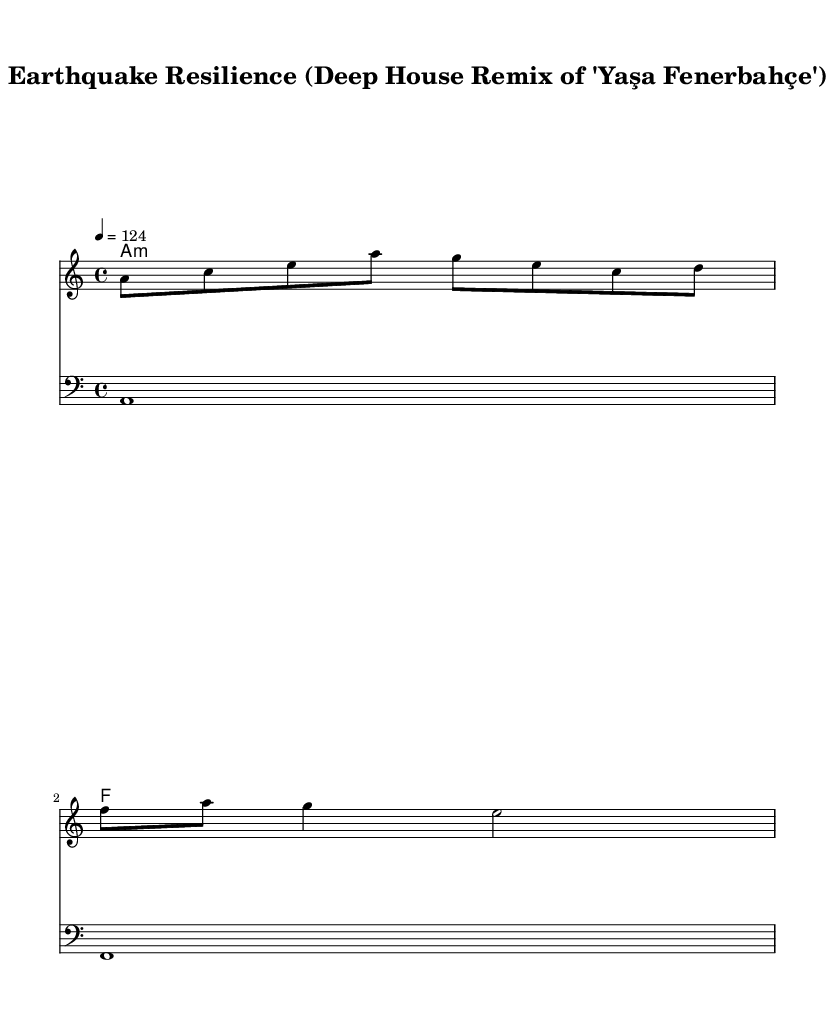What is the key signature of this music? The key signature is indicated at the beginning of the sheet music, showing one flat, which corresponds to A minor.
Answer: A minor What is the time signature of this music? The time signature is found at the beginning of the staff, and it shows that there are four beats in each measure, making it a 4/4 time signature.
Answer: 4/4 What is the tempo of this music? The tempo is provided above the staff, which indicates the speed at which the music should be played; it is marked as 124 beats per minute.
Answer: 124 How many measures are in the melody? By counting the bars in the melody line, we can see there are three measures, as indicated by the bar lines separating each group of notes.
Answer: 3 What is the root chord of the first harmony? The first harmony written at the beginning clearly shows an A minor chord, which consists of the notes A, C, and E.
Answer: A minor Which musical style does this piece belong to? This piece is described as a "Deep House Remix," which is a style of electronic dance music characterized by a repetitive beat and often incorporates soulful or jazzy influences.
Answer: Deep House How many beats does the first measure of the melody have? The first measure is made up of eight eighth notes, which together contribute to a total of four beats since each group of two eighth notes counts as one beat.
Answer: 4 